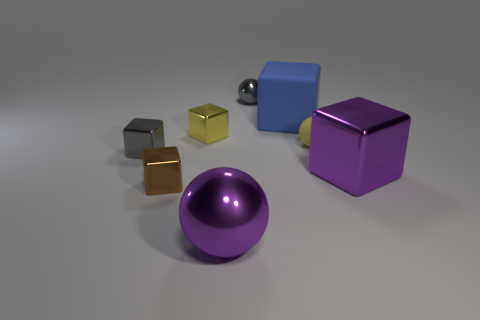What color is the small object in front of the purple shiny thing behind the object in front of the tiny brown shiny thing?
Offer a very short reply. Brown. There is a big purple thing to the right of the tiny yellow ball; are there any blue matte objects in front of it?
Ensure brevity in your answer.  No. Does the large metal thing to the left of the big metal block have the same shape as the small yellow metallic thing?
Your answer should be compact. No. What number of balls are yellow objects or large blue rubber objects?
Give a very brief answer. 1. How many big green rubber objects are there?
Your answer should be very brief. 0. There is a metal cube behind the sphere on the right side of the gray metal ball; what size is it?
Provide a succinct answer. Small. What number of other objects are there of the same size as the purple sphere?
Your answer should be very brief. 2. There is a large purple cube; how many tiny brown things are behind it?
Give a very brief answer. 0. What is the size of the blue thing?
Offer a terse response. Large. Are the tiny yellow thing that is right of the large blue thing and the gray object that is to the right of the big purple ball made of the same material?
Provide a short and direct response. No. 